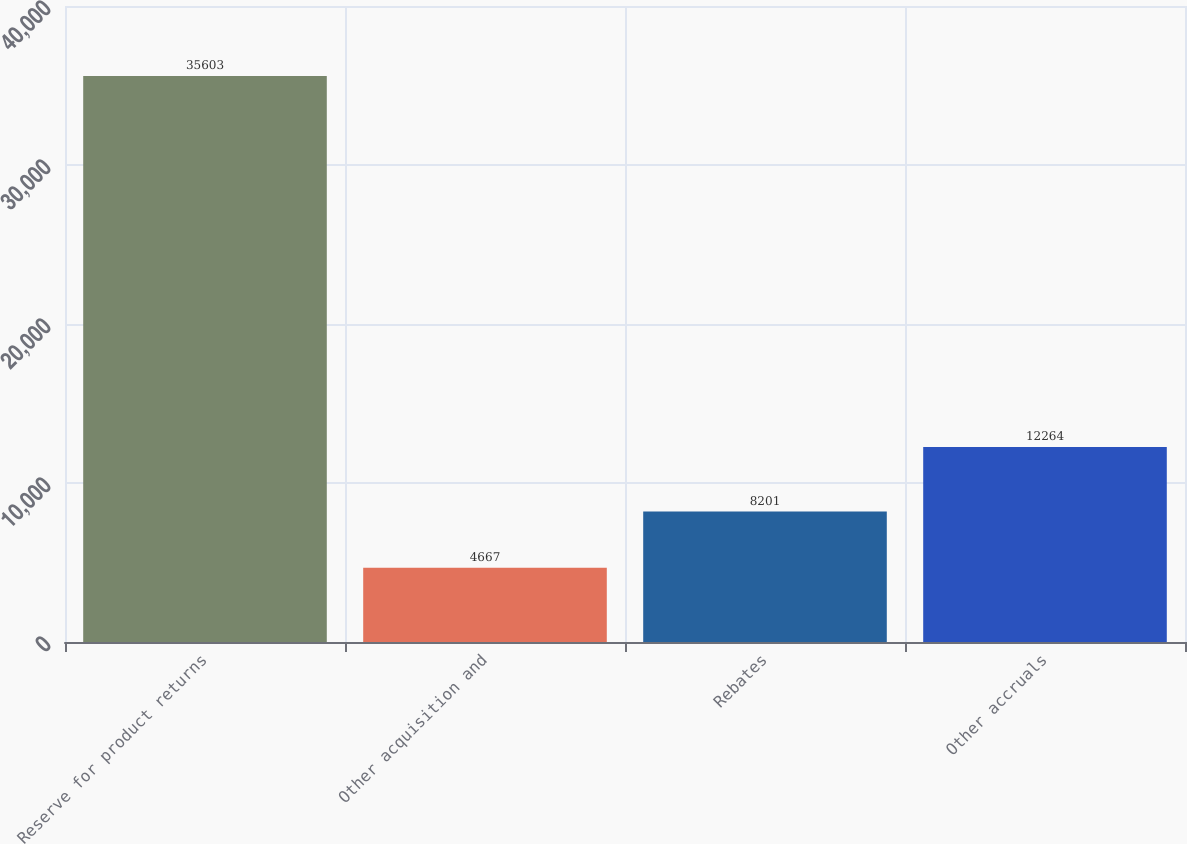<chart> <loc_0><loc_0><loc_500><loc_500><bar_chart><fcel>Reserve for product returns<fcel>Other acquisition and<fcel>Rebates<fcel>Other accruals<nl><fcel>35603<fcel>4667<fcel>8201<fcel>12264<nl></chart> 